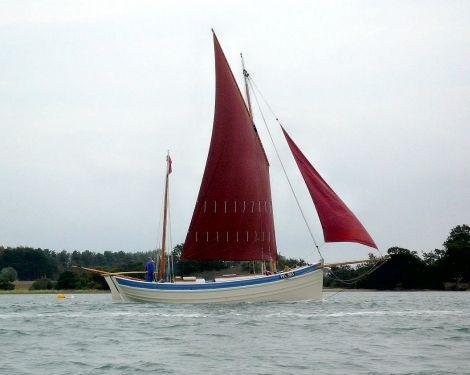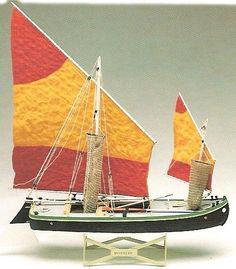The first image is the image on the left, the second image is the image on the right. For the images displayed, is the sentence "One of the boats has brown sails and a red bottom." factually correct? Answer yes or no. No. 